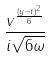Convert formula to latex. <formula><loc_0><loc_0><loc_500><loc_500>\frac { v ^ { \frac { ( y - t ) ^ { 2 } } { 6 } } } { i \sqrt { 6 \omega } }</formula> 